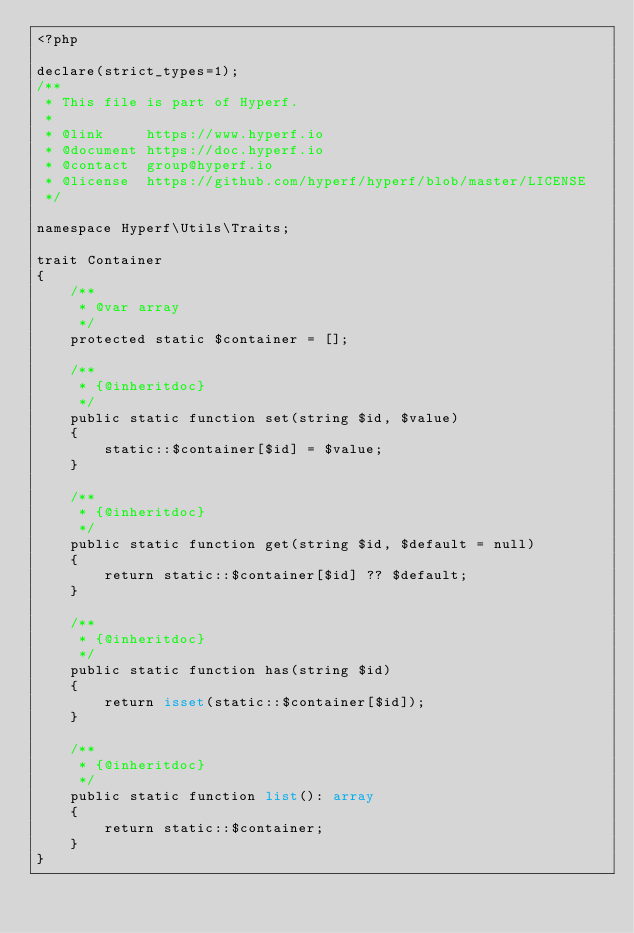<code> <loc_0><loc_0><loc_500><loc_500><_PHP_><?php

declare(strict_types=1);
/**
 * This file is part of Hyperf.
 *
 * @link     https://www.hyperf.io
 * @document https://doc.hyperf.io
 * @contact  group@hyperf.io
 * @license  https://github.com/hyperf/hyperf/blob/master/LICENSE
 */

namespace Hyperf\Utils\Traits;

trait Container
{
    /**
     * @var array
     */
    protected static $container = [];

    /**
     * {@inheritdoc}
     */
    public static function set(string $id, $value)
    {
        static::$container[$id] = $value;
    }

    /**
     * {@inheritdoc}
     */
    public static function get(string $id, $default = null)
    {
        return static::$container[$id] ?? $default;
    }

    /**
     * {@inheritdoc}
     */
    public static function has(string $id)
    {
        return isset(static::$container[$id]);
    }

    /**
     * {@inheritdoc}
     */
    public static function list(): array
    {
        return static::$container;
    }
}
</code> 